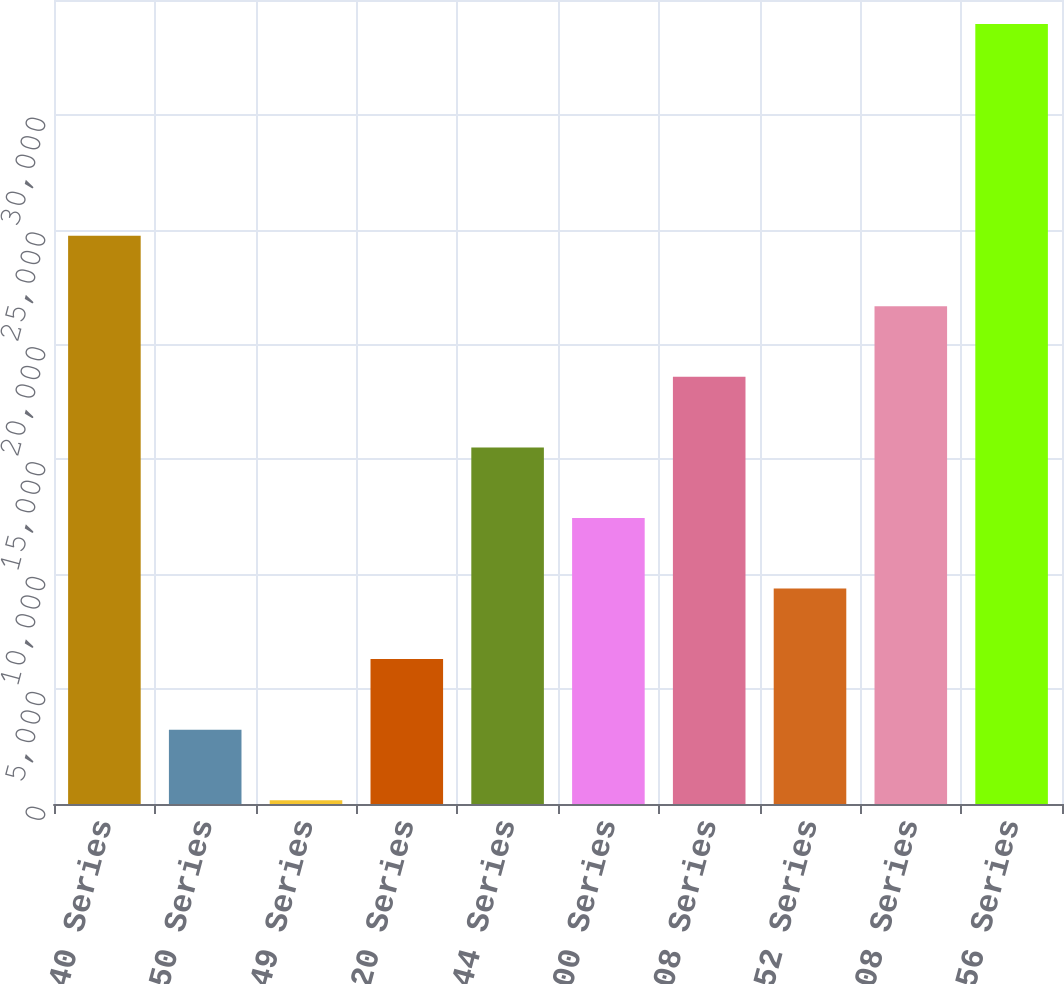Convert chart. <chart><loc_0><loc_0><loc_500><loc_500><bar_chart><fcel>440 Series<fcel>450 Series<fcel>440 1949 Series<fcel>420 Series<fcel>444 Series<fcel>500 Series<fcel>508 Series<fcel>452 Series<fcel>608 Series<fcel>756 Series<nl><fcel>24739.6<fcel>3237.7<fcel>166<fcel>6309.4<fcel>15524.5<fcel>12452.8<fcel>18596.2<fcel>9381.1<fcel>21667.9<fcel>33954.7<nl></chart> 